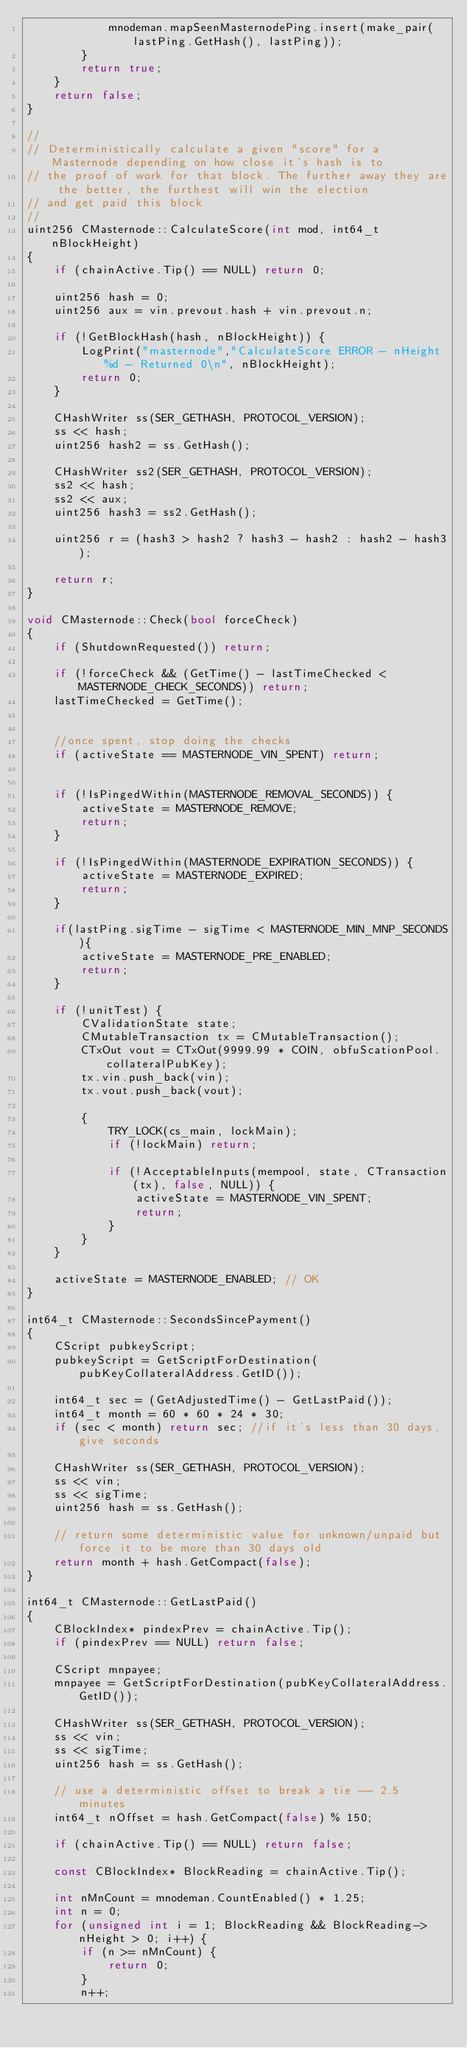<code> <loc_0><loc_0><loc_500><loc_500><_C++_>            mnodeman.mapSeenMasternodePing.insert(make_pair(lastPing.GetHash(), lastPing));
        }
        return true;
    }
    return false;
}

//
// Deterministically calculate a given "score" for a Masternode depending on how close it's hash is to
// the proof of work for that block. The further away they are the better, the furthest will win the election
// and get paid this block
//
uint256 CMasternode::CalculateScore(int mod, int64_t nBlockHeight)
{
    if (chainActive.Tip() == NULL) return 0;

    uint256 hash = 0;
    uint256 aux = vin.prevout.hash + vin.prevout.n;

    if (!GetBlockHash(hash, nBlockHeight)) {
        LogPrint("masternode","CalculateScore ERROR - nHeight %d - Returned 0\n", nBlockHeight);
        return 0;
    }

    CHashWriter ss(SER_GETHASH, PROTOCOL_VERSION);
    ss << hash;
    uint256 hash2 = ss.GetHash();

    CHashWriter ss2(SER_GETHASH, PROTOCOL_VERSION);
    ss2 << hash;
    ss2 << aux;
    uint256 hash3 = ss2.GetHash();

    uint256 r = (hash3 > hash2 ? hash3 - hash2 : hash2 - hash3);

    return r;
}

void CMasternode::Check(bool forceCheck)
{
    if (ShutdownRequested()) return;

    if (!forceCheck && (GetTime() - lastTimeChecked < MASTERNODE_CHECK_SECONDS)) return;
    lastTimeChecked = GetTime();


    //once spent, stop doing the checks
    if (activeState == MASTERNODE_VIN_SPENT) return;


    if (!IsPingedWithin(MASTERNODE_REMOVAL_SECONDS)) {
        activeState = MASTERNODE_REMOVE;
        return;
    }

    if (!IsPingedWithin(MASTERNODE_EXPIRATION_SECONDS)) {
        activeState = MASTERNODE_EXPIRED;
        return;
    }

    if(lastPing.sigTime - sigTime < MASTERNODE_MIN_MNP_SECONDS){
    	activeState = MASTERNODE_PRE_ENABLED;
    	return;
    }

    if (!unitTest) {
        CValidationState state;
        CMutableTransaction tx = CMutableTransaction();
        CTxOut vout = CTxOut(9999.99 * COIN, obfuScationPool.collateralPubKey);
        tx.vin.push_back(vin);
        tx.vout.push_back(vout);

        {
            TRY_LOCK(cs_main, lockMain);
            if (!lockMain) return;

            if (!AcceptableInputs(mempool, state, CTransaction(tx), false, NULL)) {
                activeState = MASTERNODE_VIN_SPENT;
                return;
            }
        }
    }

    activeState = MASTERNODE_ENABLED; // OK
}

int64_t CMasternode::SecondsSincePayment()
{
    CScript pubkeyScript;
    pubkeyScript = GetScriptForDestination(pubKeyCollateralAddress.GetID());

    int64_t sec = (GetAdjustedTime() - GetLastPaid());
    int64_t month = 60 * 60 * 24 * 30;
    if (sec < month) return sec; //if it's less than 30 days, give seconds

    CHashWriter ss(SER_GETHASH, PROTOCOL_VERSION);
    ss << vin;
    ss << sigTime;
    uint256 hash = ss.GetHash();

    // return some deterministic value for unknown/unpaid but force it to be more than 30 days old
    return month + hash.GetCompact(false);
}

int64_t CMasternode::GetLastPaid()
{
    CBlockIndex* pindexPrev = chainActive.Tip();
    if (pindexPrev == NULL) return false;

    CScript mnpayee;
    mnpayee = GetScriptForDestination(pubKeyCollateralAddress.GetID());

    CHashWriter ss(SER_GETHASH, PROTOCOL_VERSION);
    ss << vin;
    ss << sigTime;
    uint256 hash = ss.GetHash();

    // use a deterministic offset to break a tie -- 2.5 minutes
    int64_t nOffset = hash.GetCompact(false) % 150;

    if (chainActive.Tip() == NULL) return false;

    const CBlockIndex* BlockReading = chainActive.Tip();

    int nMnCount = mnodeman.CountEnabled() * 1.25;
    int n = 0;
    for (unsigned int i = 1; BlockReading && BlockReading->nHeight > 0; i++) {
        if (n >= nMnCount) {
            return 0;
        }
        n++;
</code> 